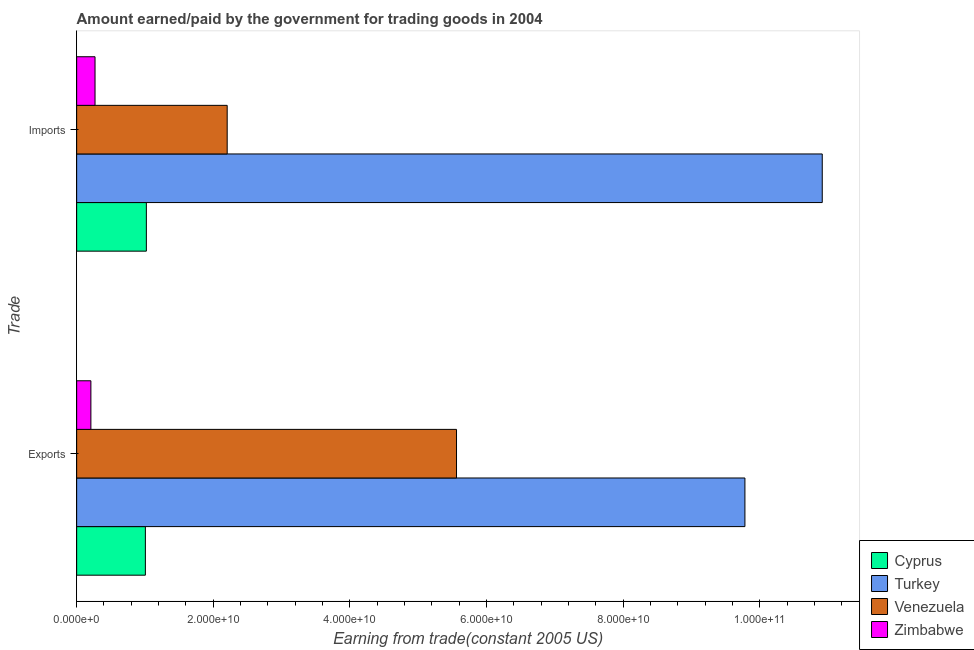Are the number of bars per tick equal to the number of legend labels?
Give a very brief answer. Yes. Are the number of bars on each tick of the Y-axis equal?
Give a very brief answer. Yes. How many bars are there on the 2nd tick from the top?
Your answer should be compact. 4. What is the label of the 2nd group of bars from the top?
Your answer should be very brief. Exports. What is the amount paid for imports in Turkey?
Your response must be concise. 1.09e+11. Across all countries, what is the maximum amount paid for imports?
Your response must be concise. 1.09e+11. Across all countries, what is the minimum amount paid for imports?
Provide a succinct answer. 2.69e+09. In which country was the amount earned from exports minimum?
Ensure brevity in your answer.  Zimbabwe. What is the total amount paid for imports in the graph?
Your answer should be compact. 1.44e+11. What is the difference between the amount paid for imports in Venezuela and that in Cyprus?
Give a very brief answer. 1.18e+1. What is the difference between the amount paid for imports in Cyprus and the amount earned from exports in Venezuela?
Give a very brief answer. -4.54e+1. What is the average amount paid for imports per country?
Your answer should be compact. 3.60e+1. What is the difference between the amount earned from exports and amount paid for imports in Zimbabwe?
Ensure brevity in your answer.  -6.06e+08. What is the ratio of the amount earned from exports in Zimbabwe to that in Cyprus?
Provide a short and direct response. 0.21. What does the 2nd bar from the top in Exports represents?
Give a very brief answer. Venezuela. What does the 4th bar from the bottom in Exports represents?
Keep it short and to the point. Zimbabwe. How many countries are there in the graph?
Your response must be concise. 4. Are the values on the major ticks of X-axis written in scientific E-notation?
Provide a short and direct response. Yes. Does the graph contain any zero values?
Provide a short and direct response. No. How many legend labels are there?
Your answer should be compact. 4. What is the title of the graph?
Ensure brevity in your answer.  Amount earned/paid by the government for trading goods in 2004. Does "Ecuador" appear as one of the legend labels in the graph?
Your answer should be very brief. No. What is the label or title of the X-axis?
Your response must be concise. Earning from trade(constant 2005 US). What is the label or title of the Y-axis?
Provide a succinct answer. Trade. What is the Earning from trade(constant 2005 US) of Cyprus in Exports?
Provide a short and direct response. 1.01e+1. What is the Earning from trade(constant 2005 US) in Turkey in Exports?
Your response must be concise. 9.78e+1. What is the Earning from trade(constant 2005 US) of Venezuela in Exports?
Offer a terse response. 5.56e+1. What is the Earning from trade(constant 2005 US) of Zimbabwe in Exports?
Offer a very short reply. 2.08e+09. What is the Earning from trade(constant 2005 US) in Cyprus in Imports?
Give a very brief answer. 1.02e+1. What is the Earning from trade(constant 2005 US) in Turkey in Imports?
Keep it short and to the point. 1.09e+11. What is the Earning from trade(constant 2005 US) in Venezuela in Imports?
Make the answer very short. 2.20e+1. What is the Earning from trade(constant 2005 US) in Zimbabwe in Imports?
Make the answer very short. 2.69e+09. Across all Trade, what is the maximum Earning from trade(constant 2005 US) of Cyprus?
Keep it short and to the point. 1.02e+1. Across all Trade, what is the maximum Earning from trade(constant 2005 US) of Turkey?
Offer a terse response. 1.09e+11. Across all Trade, what is the maximum Earning from trade(constant 2005 US) in Venezuela?
Provide a short and direct response. 5.56e+1. Across all Trade, what is the maximum Earning from trade(constant 2005 US) of Zimbabwe?
Your response must be concise. 2.69e+09. Across all Trade, what is the minimum Earning from trade(constant 2005 US) of Cyprus?
Provide a succinct answer. 1.01e+1. Across all Trade, what is the minimum Earning from trade(constant 2005 US) of Turkey?
Make the answer very short. 9.78e+1. Across all Trade, what is the minimum Earning from trade(constant 2005 US) of Venezuela?
Your answer should be compact. 2.20e+1. Across all Trade, what is the minimum Earning from trade(constant 2005 US) in Zimbabwe?
Your response must be concise. 2.08e+09. What is the total Earning from trade(constant 2005 US) in Cyprus in the graph?
Ensure brevity in your answer.  2.03e+1. What is the total Earning from trade(constant 2005 US) of Turkey in the graph?
Ensure brevity in your answer.  2.07e+11. What is the total Earning from trade(constant 2005 US) of Venezuela in the graph?
Ensure brevity in your answer.  7.76e+1. What is the total Earning from trade(constant 2005 US) in Zimbabwe in the graph?
Keep it short and to the point. 4.77e+09. What is the difference between the Earning from trade(constant 2005 US) of Cyprus in Exports and that in Imports?
Offer a terse response. -1.44e+08. What is the difference between the Earning from trade(constant 2005 US) of Turkey in Exports and that in Imports?
Your answer should be compact. -1.13e+1. What is the difference between the Earning from trade(constant 2005 US) in Venezuela in Exports and that in Imports?
Offer a terse response. 3.36e+1. What is the difference between the Earning from trade(constant 2005 US) of Zimbabwe in Exports and that in Imports?
Provide a succinct answer. -6.06e+08. What is the difference between the Earning from trade(constant 2005 US) of Cyprus in Exports and the Earning from trade(constant 2005 US) of Turkey in Imports?
Provide a succinct answer. -9.91e+1. What is the difference between the Earning from trade(constant 2005 US) in Cyprus in Exports and the Earning from trade(constant 2005 US) in Venezuela in Imports?
Keep it short and to the point. -1.20e+1. What is the difference between the Earning from trade(constant 2005 US) of Cyprus in Exports and the Earning from trade(constant 2005 US) of Zimbabwe in Imports?
Provide a succinct answer. 7.37e+09. What is the difference between the Earning from trade(constant 2005 US) of Turkey in Exports and the Earning from trade(constant 2005 US) of Venezuela in Imports?
Your answer should be compact. 7.58e+1. What is the difference between the Earning from trade(constant 2005 US) in Turkey in Exports and the Earning from trade(constant 2005 US) in Zimbabwe in Imports?
Make the answer very short. 9.51e+1. What is the difference between the Earning from trade(constant 2005 US) of Venezuela in Exports and the Earning from trade(constant 2005 US) of Zimbabwe in Imports?
Ensure brevity in your answer.  5.29e+1. What is the average Earning from trade(constant 2005 US) in Cyprus per Trade?
Your response must be concise. 1.01e+1. What is the average Earning from trade(constant 2005 US) in Turkey per Trade?
Offer a terse response. 1.03e+11. What is the average Earning from trade(constant 2005 US) in Venezuela per Trade?
Your answer should be compact. 3.88e+1. What is the average Earning from trade(constant 2005 US) of Zimbabwe per Trade?
Provide a succinct answer. 2.39e+09. What is the difference between the Earning from trade(constant 2005 US) in Cyprus and Earning from trade(constant 2005 US) in Turkey in Exports?
Ensure brevity in your answer.  -8.78e+1. What is the difference between the Earning from trade(constant 2005 US) in Cyprus and Earning from trade(constant 2005 US) in Venezuela in Exports?
Make the answer very short. -4.56e+1. What is the difference between the Earning from trade(constant 2005 US) in Cyprus and Earning from trade(constant 2005 US) in Zimbabwe in Exports?
Offer a terse response. 7.98e+09. What is the difference between the Earning from trade(constant 2005 US) of Turkey and Earning from trade(constant 2005 US) of Venezuela in Exports?
Ensure brevity in your answer.  4.22e+1. What is the difference between the Earning from trade(constant 2005 US) in Turkey and Earning from trade(constant 2005 US) in Zimbabwe in Exports?
Provide a short and direct response. 9.58e+1. What is the difference between the Earning from trade(constant 2005 US) in Venezuela and Earning from trade(constant 2005 US) in Zimbabwe in Exports?
Make the answer very short. 5.35e+1. What is the difference between the Earning from trade(constant 2005 US) in Cyprus and Earning from trade(constant 2005 US) in Turkey in Imports?
Provide a short and direct response. -9.90e+1. What is the difference between the Earning from trade(constant 2005 US) in Cyprus and Earning from trade(constant 2005 US) in Venezuela in Imports?
Keep it short and to the point. -1.18e+1. What is the difference between the Earning from trade(constant 2005 US) in Cyprus and Earning from trade(constant 2005 US) in Zimbabwe in Imports?
Your response must be concise. 7.51e+09. What is the difference between the Earning from trade(constant 2005 US) of Turkey and Earning from trade(constant 2005 US) of Venezuela in Imports?
Offer a terse response. 8.71e+1. What is the difference between the Earning from trade(constant 2005 US) of Turkey and Earning from trade(constant 2005 US) of Zimbabwe in Imports?
Provide a succinct answer. 1.06e+11. What is the difference between the Earning from trade(constant 2005 US) of Venezuela and Earning from trade(constant 2005 US) of Zimbabwe in Imports?
Provide a short and direct response. 1.93e+1. What is the ratio of the Earning from trade(constant 2005 US) of Cyprus in Exports to that in Imports?
Give a very brief answer. 0.99. What is the ratio of the Earning from trade(constant 2005 US) of Turkey in Exports to that in Imports?
Offer a very short reply. 0.9. What is the ratio of the Earning from trade(constant 2005 US) in Venezuela in Exports to that in Imports?
Ensure brevity in your answer.  2.52. What is the ratio of the Earning from trade(constant 2005 US) of Zimbabwe in Exports to that in Imports?
Provide a short and direct response. 0.77. What is the difference between the highest and the second highest Earning from trade(constant 2005 US) of Cyprus?
Make the answer very short. 1.44e+08. What is the difference between the highest and the second highest Earning from trade(constant 2005 US) in Turkey?
Provide a short and direct response. 1.13e+1. What is the difference between the highest and the second highest Earning from trade(constant 2005 US) in Venezuela?
Ensure brevity in your answer.  3.36e+1. What is the difference between the highest and the second highest Earning from trade(constant 2005 US) of Zimbabwe?
Provide a short and direct response. 6.06e+08. What is the difference between the highest and the lowest Earning from trade(constant 2005 US) of Cyprus?
Provide a short and direct response. 1.44e+08. What is the difference between the highest and the lowest Earning from trade(constant 2005 US) of Turkey?
Your answer should be very brief. 1.13e+1. What is the difference between the highest and the lowest Earning from trade(constant 2005 US) of Venezuela?
Your answer should be very brief. 3.36e+1. What is the difference between the highest and the lowest Earning from trade(constant 2005 US) in Zimbabwe?
Keep it short and to the point. 6.06e+08. 